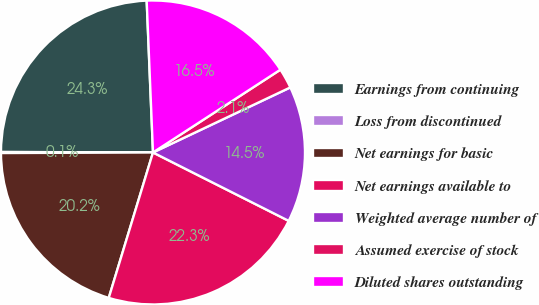<chart> <loc_0><loc_0><loc_500><loc_500><pie_chart><fcel>Earnings from continuing<fcel>Loss from discontinued<fcel>Net earnings for basic<fcel>Net earnings available to<fcel>Weighted average number of<fcel>Assumed exercise of stock<fcel>Diluted shares outstanding<nl><fcel>24.29%<fcel>0.11%<fcel>20.24%<fcel>22.27%<fcel>14.47%<fcel>2.13%<fcel>16.49%<nl></chart> 